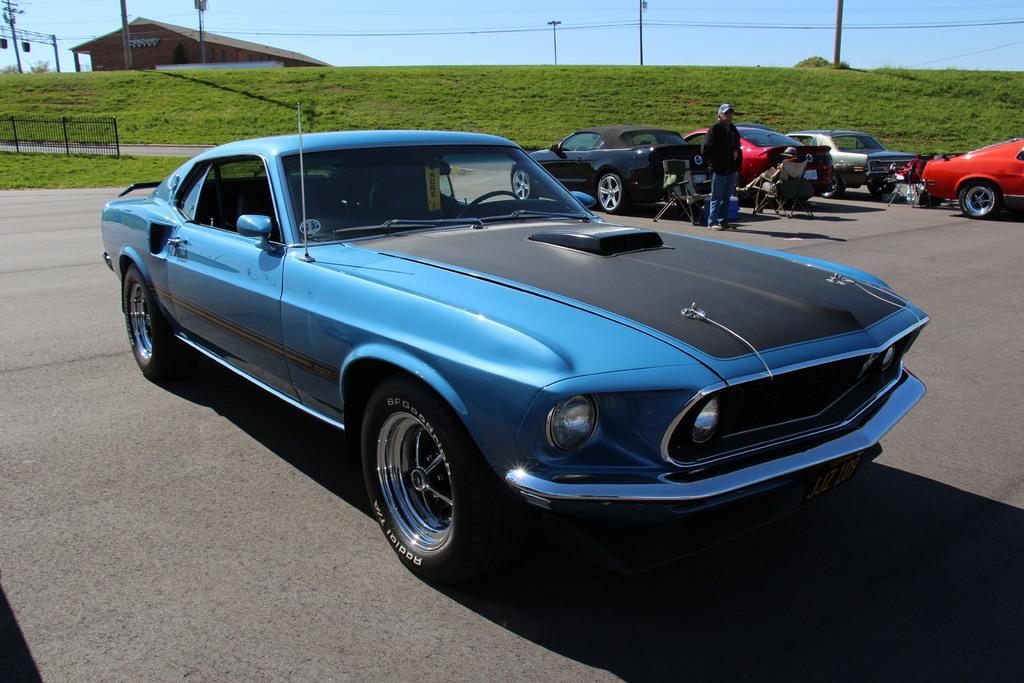Please provide a concise description of this image. In this image, there are a few vehicles. We can see some people. Among them, we can see a person sitting. We can see the ground with some objects. We can see some poles, wires and the sky. We can see some grass and a house. We can also see the fence. 